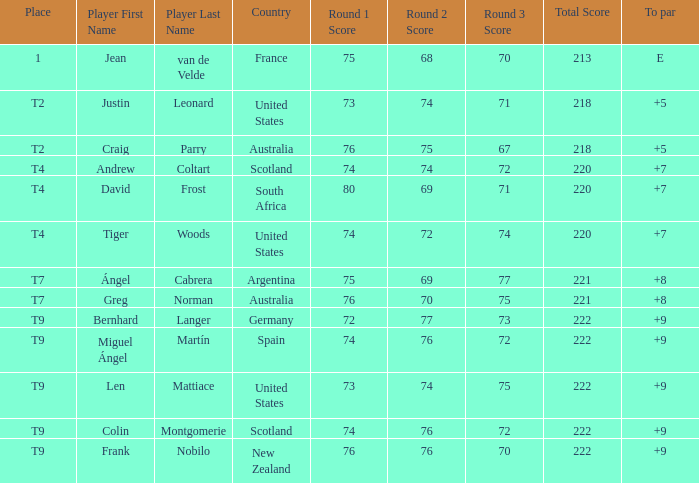Which player from the United States is in a place of T2? Justin Leonard. 